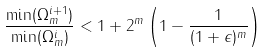<formula> <loc_0><loc_0><loc_500><loc_500>\frac { \min ( \Omega _ { m } ^ { i + 1 } ) } { \min ( \Omega _ { m } ^ { i } ) } < 1 + 2 ^ { m } \left ( 1 - \frac { 1 } { ( 1 + \epsilon ) ^ { m } } \right )</formula> 